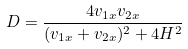Convert formula to latex. <formula><loc_0><loc_0><loc_500><loc_500>D = \frac { 4 v _ { 1 x } v _ { 2 x } } { ( v _ { 1 x } + v _ { 2 x } ) ^ { 2 } + 4 H ^ { 2 } }</formula> 